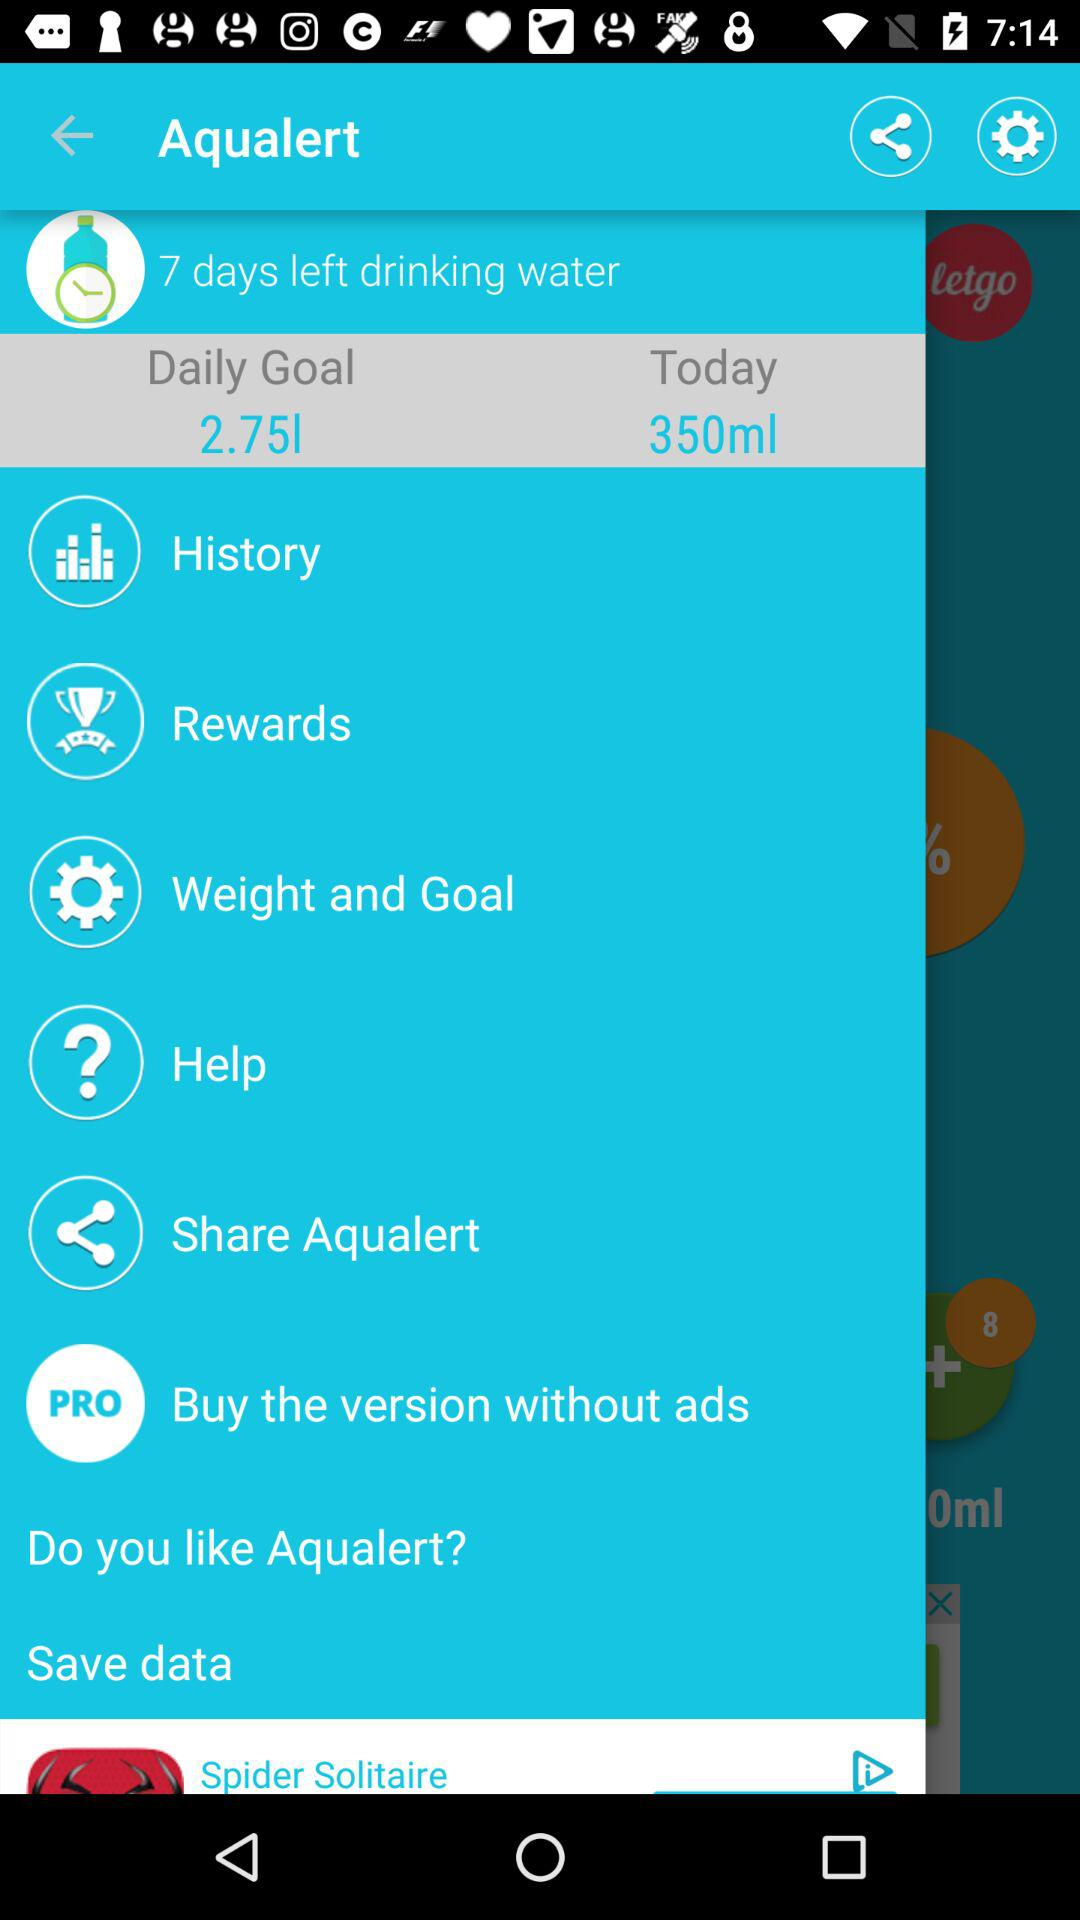What is the quantity for "Today"? The quantity is 350ml. 